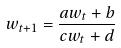Convert formula to latex. <formula><loc_0><loc_0><loc_500><loc_500>w _ { t + 1 } = \frac { a w _ { t } + b } { c w _ { t } + d }</formula> 